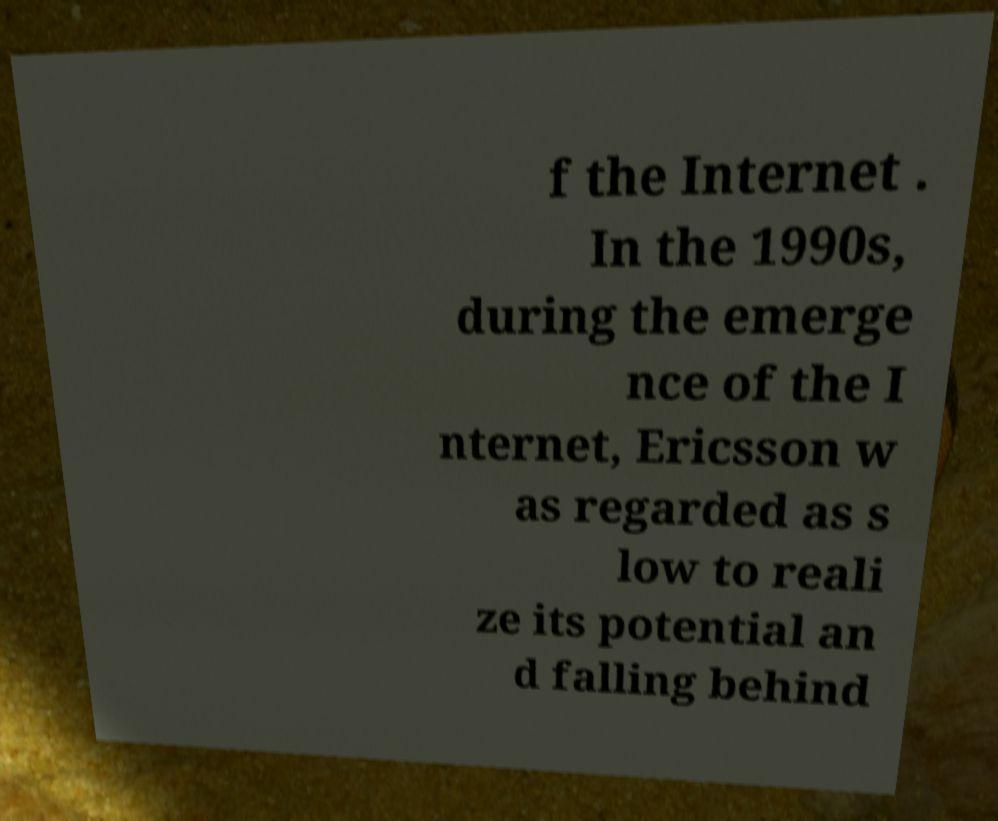Please read and relay the text visible in this image. What does it say? f the Internet . In the 1990s, during the emerge nce of the I nternet, Ericsson w as regarded as s low to reali ze its potential an d falling behind 